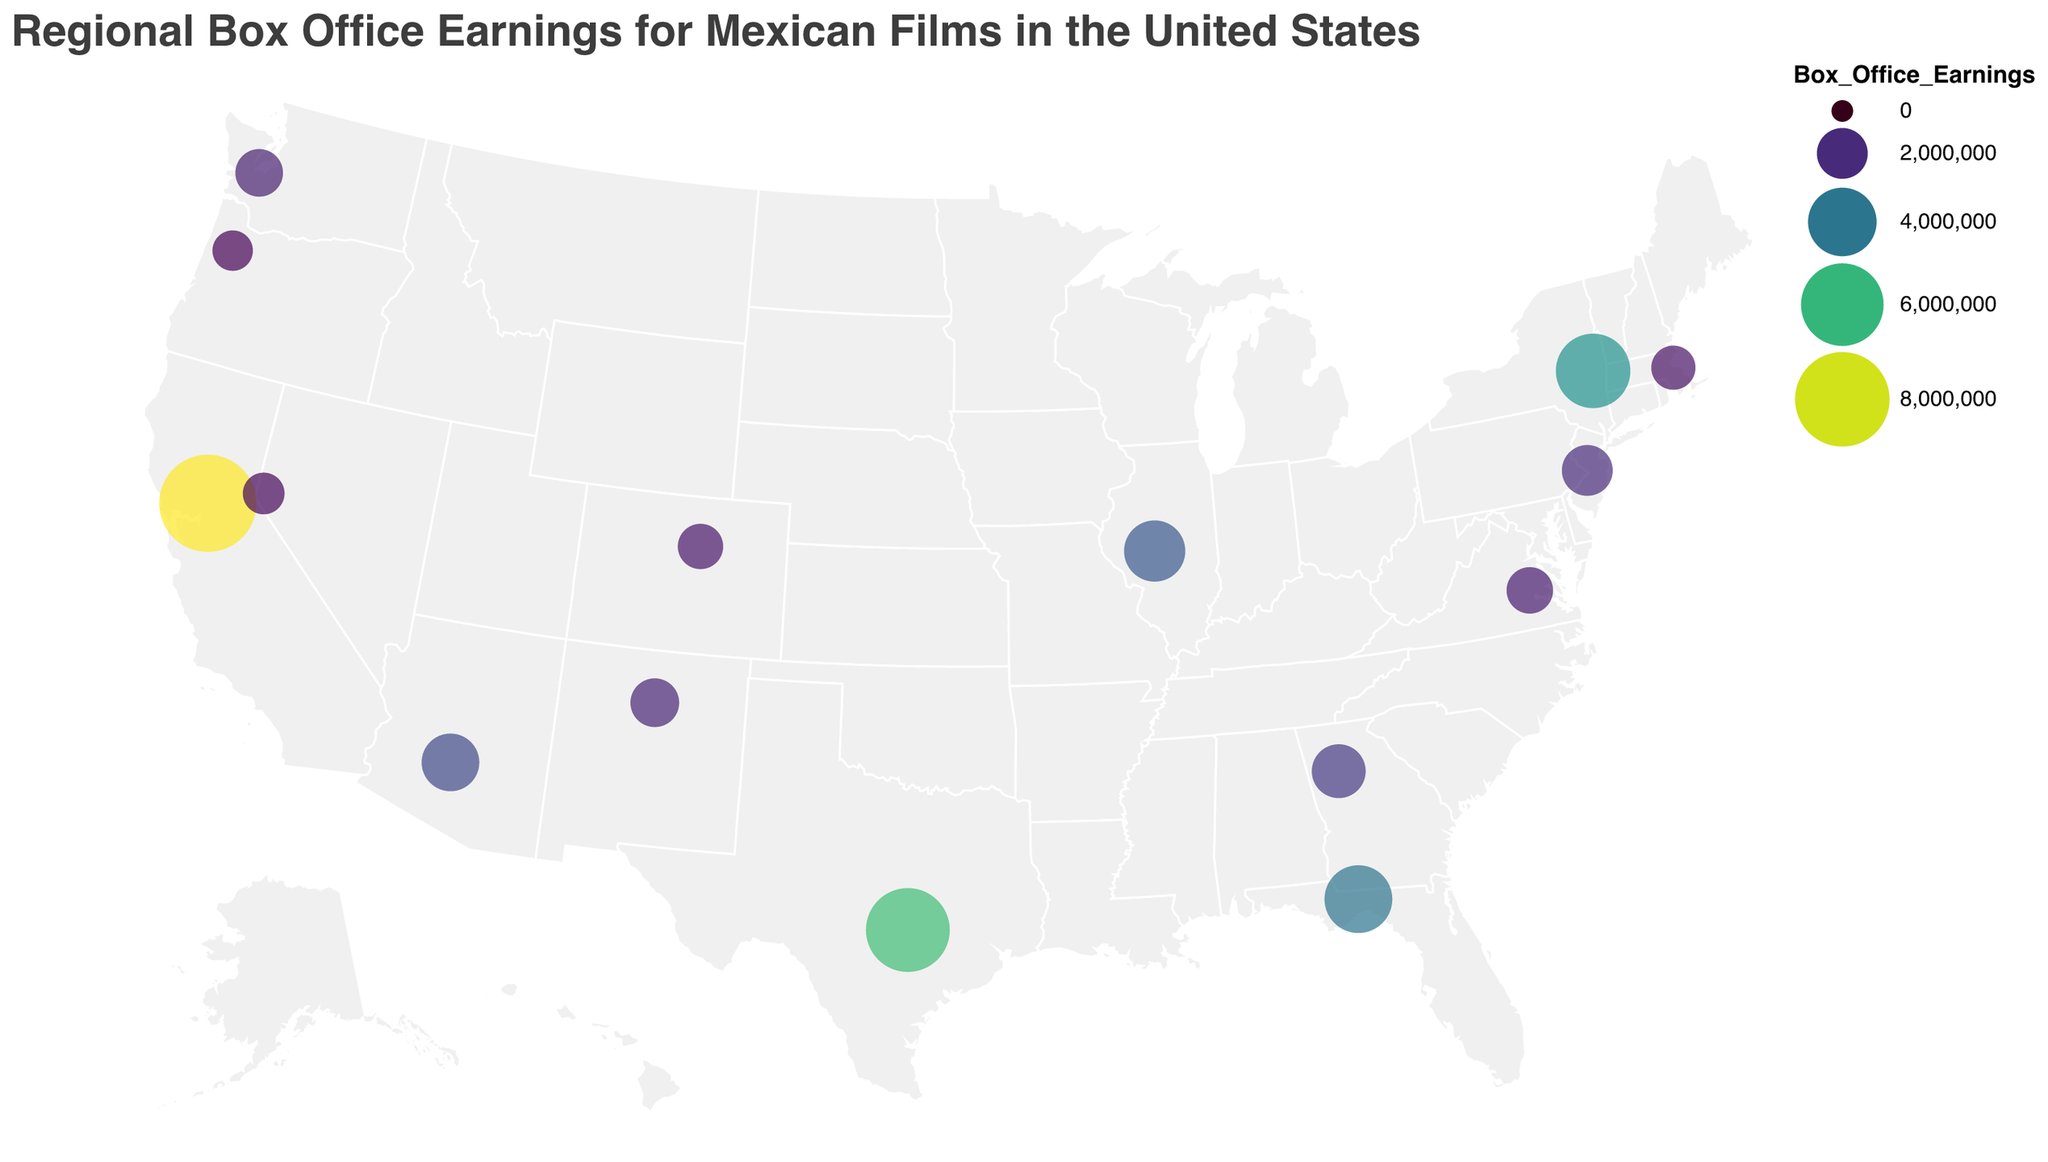What is the title of the plot? The title is usually displayed at the top of the plot and provides an overview of what the plot is about. Here, we see the title at the top which reads "Regional Box Office Earnings for Mexican Films in the United States".
Answer: Regional Box Office Earnings for Mexican Films in the United States Which state has the highest box office earnings? By looking at the circle sizes and colors on the map, we can determine which state has the largest circle with the darkest shade. California has the largest and darkest circle indicating the highest earnings.
Answer: California Which state has the lowest box office earnings? The smallest and lightest circle on the map represents the state with the lowest earnings. Oregon has the smallest and lightest circle, indicating the lowest earnings.
Answer: Oregon What's the combined box office earnings for Texas and New York? To find the combined earnings, sum the box office earnings for Texas and New York. Texas has $6,200,000 and New York has $4,800,000. Adding them together gives $6,200,000 + $4,800,000 = $11,000,000.
Answer: $11,000,000 How does the box office earnings of New Jersey compare with Massachusetts? We need to compare the sizes of the circles representing New Jersey and Massachusetts. New Jersey has earnings of $2,000,000, while Massachusetts has $1,400,000. New Jersey has higher earnings than Massachusetts.
Answer: New Jersey has higher earnings Which region, East Coast or West Coast, appears to generate more box office earnings for Mexican films? The West Coast states (California, Oregon, and Washington) show significant earnings, with California having exceptionally high earnings. The East Coast (New York, New Jersey, Virginia, and Massachusetts) also shows earnings, but generally lower than those on the West Coast. Overall, the West Coast generates more earnings.
Answer: West Coast What is the difference in box office earnings between the top earning state and the state with the second-highest earnings? California is the top earning state with $8,500,000 and Texas is the second-highest with $6,200,000. The difference is $8,500,000 - $6,200,000 = $2,300,000.
Answer: $2,300,000 What is the average box office earnings across all the states? To find the average, sum the earnings of all states and divide by the number of states. Total earnings = $8,500,000 + $6,200,000 + $3,100,000 + $4,800,000 + $3,900,000 + $2,700,000 + $1,800,000 + $1,500,000 + $1,200,000 + $2,300,000 + $1,700,000 + $1,100,000 + $2,000,000 + $1,400,000 + $1,600,000 = $43,800,000. Number of states = 15. Average = $43,800,000 / 15 = $2,920,000.
Answer: $2,920,000 Which states have box office earnings greater than $3,000,000? By examining circle sizes and colors, and verifying with the data, California ($8,500,000), Texas ($6,200,000), Illinois ($3,100,000), New York ($4,800,000), and Florida ($3,900,000) have box office earnings greater than $3,000,000.
Answer: California, Texas, Illinois, New York, Florida How do the box office earnings in Arizona compare to those in New Mexico and Nevada? Arizona has box office earnings of $2,700,000. New Mexico has $1,800,000, and Nevada has $1,200,000. Comparing these, Arizona has higher box office earnings than both New Mexico and Nevada.
Answer: Higher than both 